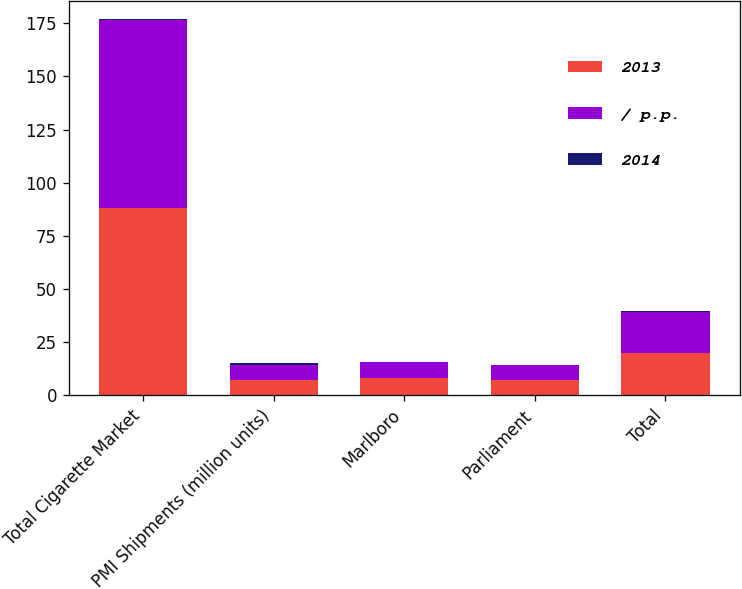Convert chart to OTSL. <chart><loc_0><loc_0><loc_500><loc_500><stacked_bar_chart><ecel><fcel>Total Cigarette Market<fcel>PMI Shipments (million units)<fcel>Marlboro<fcel>Parliament<fcel>Total<nl><fcel>2013<fcel>88.1<fcel>7.1<fcel>7.8<fcel>7.1<fcel>19.7<nl><fcel>/ p.p.<fcel>88.4<fcel>7.1<fcel>7.7<fcel>6.9<fcel>19.4<nl><fcel>2014<fcel>0.4<fcel>1.1<fcel>0.1<fcel>0.2<fcel>0.3<nl></chart> 